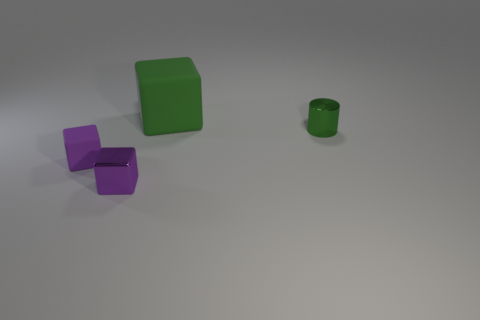What is the color of the matte block in front of the rubber thing behind the tiny green object? purple 